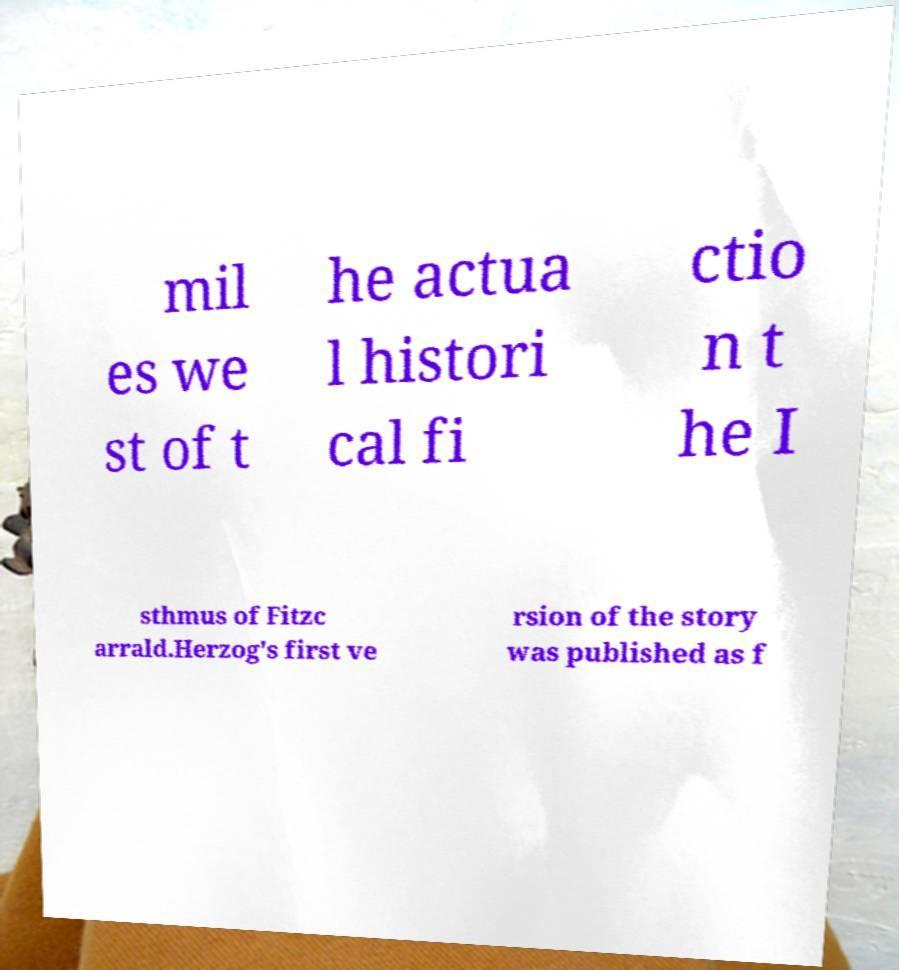Could you assist in decoding the text presented in this image and type it out clearly? mil es we st of t he actua l histori cal fi ctio n t he I sthmus of Fitzc arrald.Herzog's first ve rsion of the story was published as f 